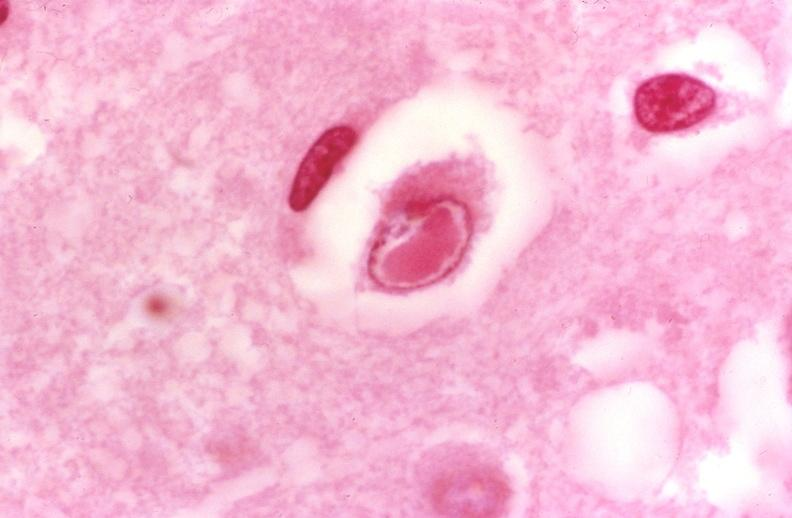s pus in test tube present?
Answer the question using a single word or phrase. No 